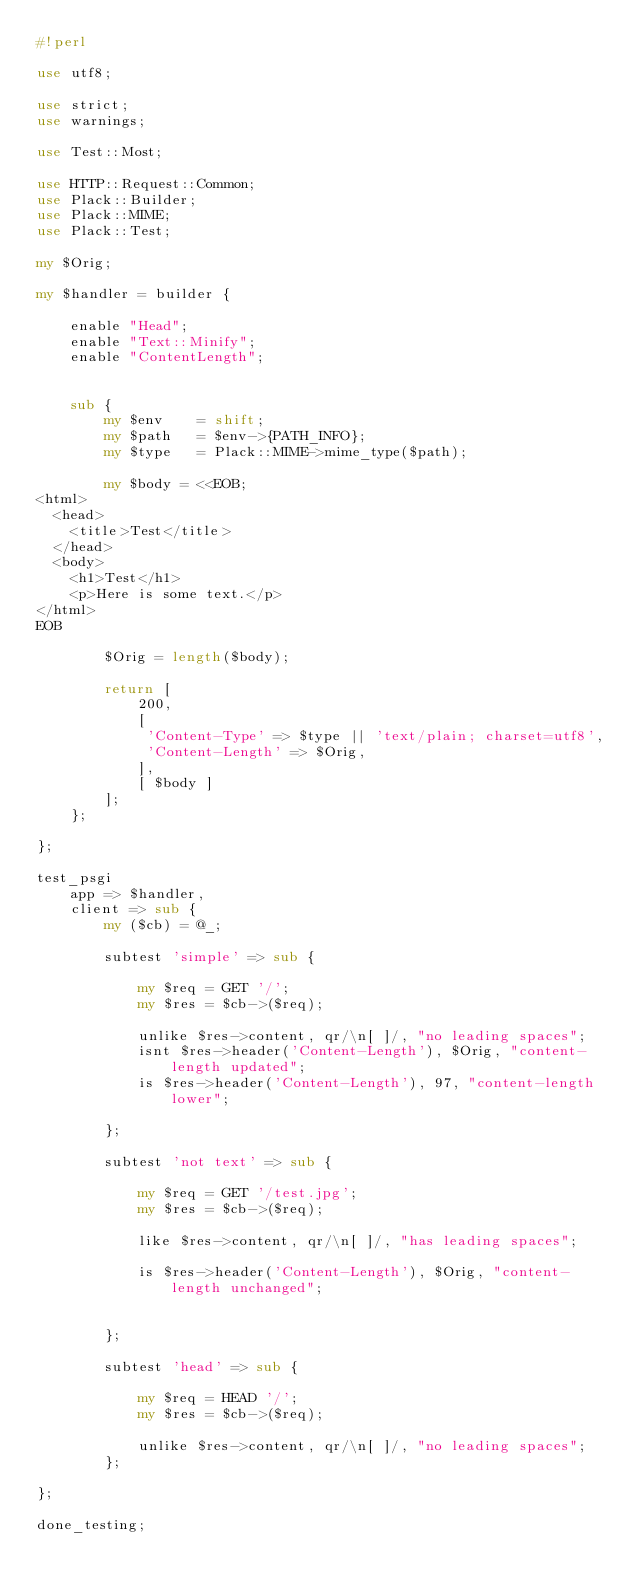<code> <loc_0><loc_0><loc_500><loc_500><_Perl_>#!perl

use utf8;

use strict;
use warnings;

use Test::Most;

use HTTP::Request::Common;
use Plack::Builder;
use Plack::MIME;
use Plack::Test;

my $Orig;

my $handler = builder {

    enable "Head";
    enable "Text::Minify";
    enable "ContentLength";


    sub {
        my $env    = shift;
        my $path   = $env->{PATH_INFO};
        my $type   = Plack::MIME->mime_type($path);

        my $body = <<EOB;
<html>
  <head>
    <title>Test</title>
  </head>
  <body>
    <h1>Test</h1>
    <p>Here is some text.</p>
</html>
EOB

        $Orig = length($body);

        return [
            200,
            [
             'Content-Type' => $type || 'text/plain; charset=utf8',
             'Content-Length' => $Orig,
            ],
            [ $body ]
        ];
    };

};

test_psgi
    app => $handler,
    client => sub {
        my ($cb) = @_;

        subtest 'simple' => sub {

            my $req = GET '/';
            my $res = $cb->($req);

            unlike $res->content, qr/\n[ ]/, "no leading spaces";
            isnt $res->header('Content-Length'), $Orig, "content-length updated";
            is $res->header('Content-Length'), 97, "content-length lower";

        };

        subtest 'not text' => sub {

            my $req = GET '/test.jpg';
            my $res = $cb->($req);

            like $res->content, qr/\n[ ]/, "has leading spaces";

            is $res->header('Content-Length'), $Orig, "content-length unchanged";


        };

        subtest 'head' => sub {

            my $req = HEAD '/';
            my $res = $cb->($req);

            unlike $res->content, qr/\n[ ]/, "no leading spaces";
        };

};

done_testing;
</code> 